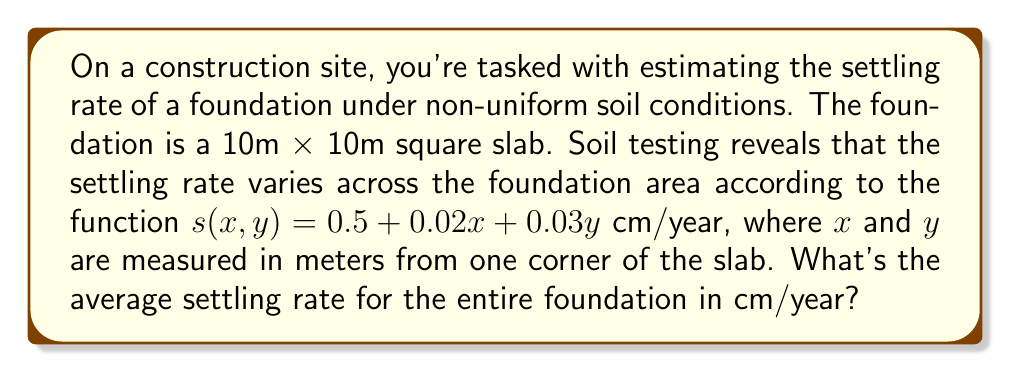Could you help me with this problem? To solve this problem, we need to follow these steps:

1) The settling rate is given by the function $s(x,y) = 0.5 + 0.02x + 0.03y$ cm/year.

2) To find the average settling rate, we need to integrate this function over the area of the foundation and divide by the total area.

3) The double integral for the average value of a function $f(x,y)$ over a rectangular region $[a,b] \times [c,d]$ is:

   $$\frac{1}{(b-a)(d-c)} \int_a^b \int_c^d f(x,y) \, dy \, dx$$

4) In our case, $a=0$, $b=10$, $c=0$, $d=10$, and the area is $10 \times 10 = 100$ m².

5) Let's set up the integral:

   $$\frac{1}{100} \int_0^{10} \int_0^{10} (0.5 + 0.02x + 0.03y) \, dy \, dx$$

6) Integrate with respect to y first:

   $$\frac{1}{100} \int_0^{10} \left[0.5y + 0.02xy + 0.015y^2\right]_0^{10} \, dx$$
   
   $$= \frac{1}{100} \int_0^{10} (5 + 0.2x + 1.5) \, dx$$
   
   $$= \frac{1}{100} \int_0^{10} (6.5 + 0.2x) \, dx$$

7) Now integrate with respect to x:

   $$\frac{1}{100} \left[6.5x + 0.1x^2\right]_0^{10}$$
   
   $$= \frac{1}{100} (65 + 10 - 0)$$
   
   $$= \frac{75}{100} = 0.75$$

Therefore, the average settling rate is 0.75 cm/year.
Answer: 0.75 cm/year 